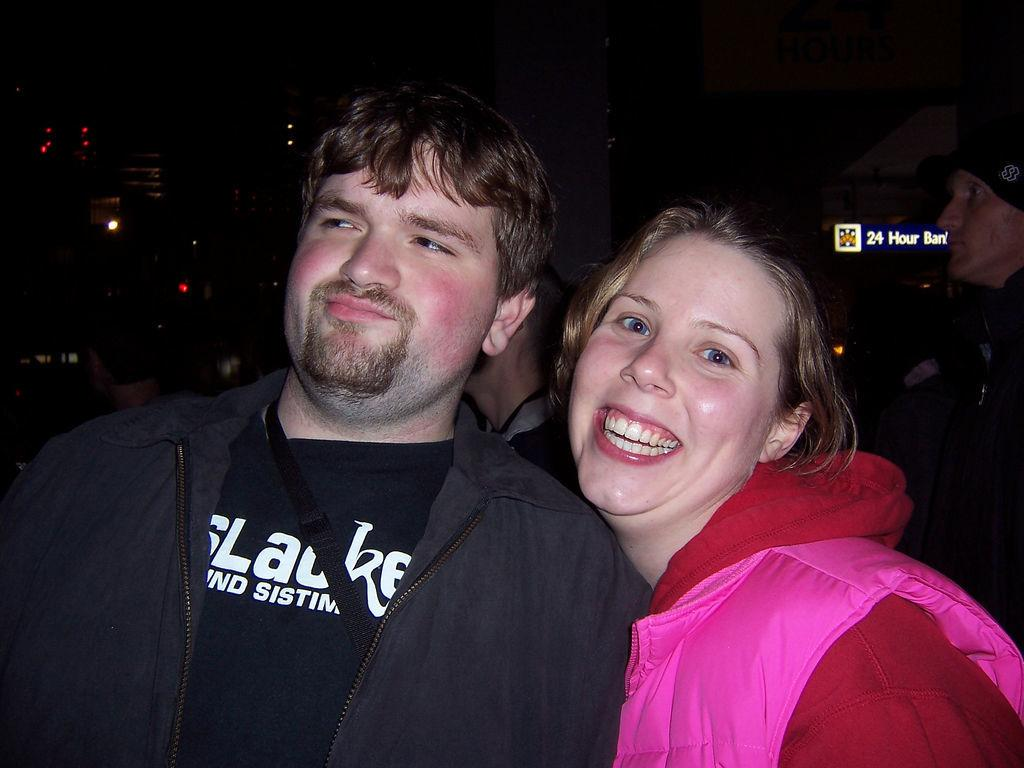How many people are in the image? There are two people in the image. What are the people doing in the image? The people are smiling and posing. What color is the background of the image? The background of the image is black. What can be seen in the background besides the black color? There are lights visible in the background. Is there any text present in the image? Yes, there is text written on the backside of something in the image. What is one person wearing in the image? One person is wearing a cap. What type of cushion is being used as a pancake in the image? There is no cushion or pancake present in the image. What calculations are being made using the calculator in the image? There is no calculator present in the image. 